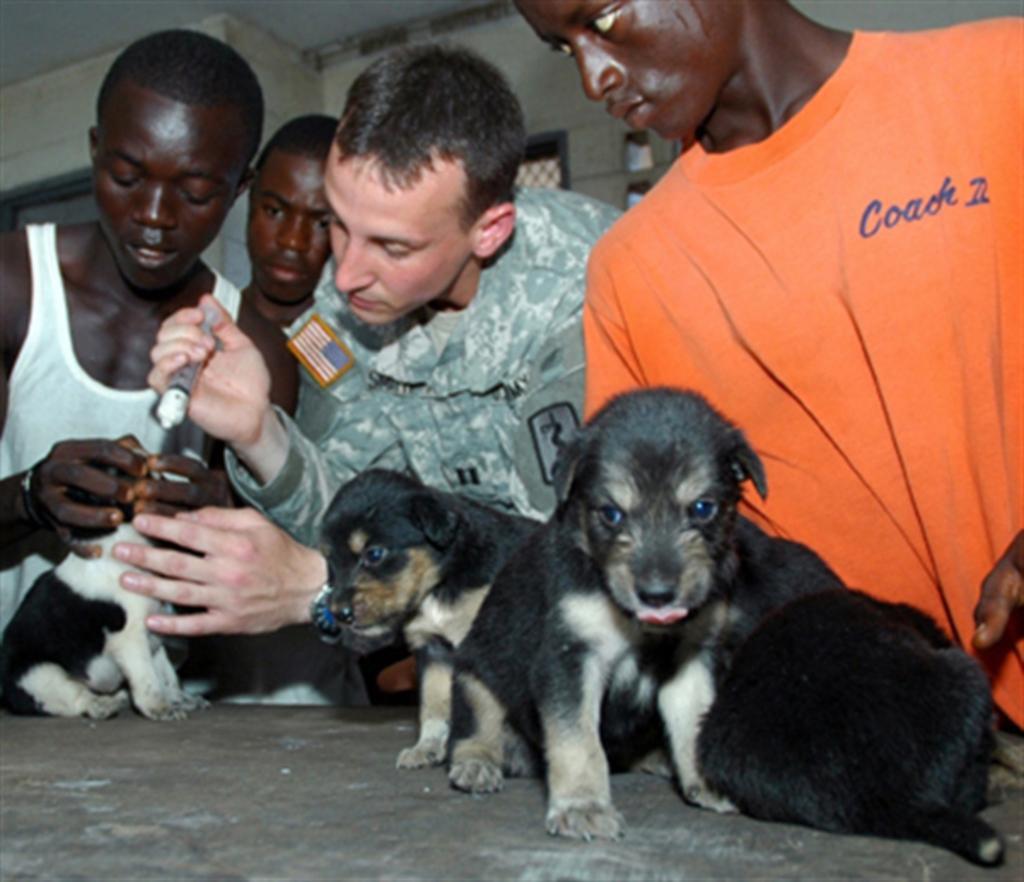Can you describe this image briefly? In the picture we can find some people are standing and one man is taking a injection, those people are near to the table, On the table we can find two dogs. In the background we can see wall and window. 